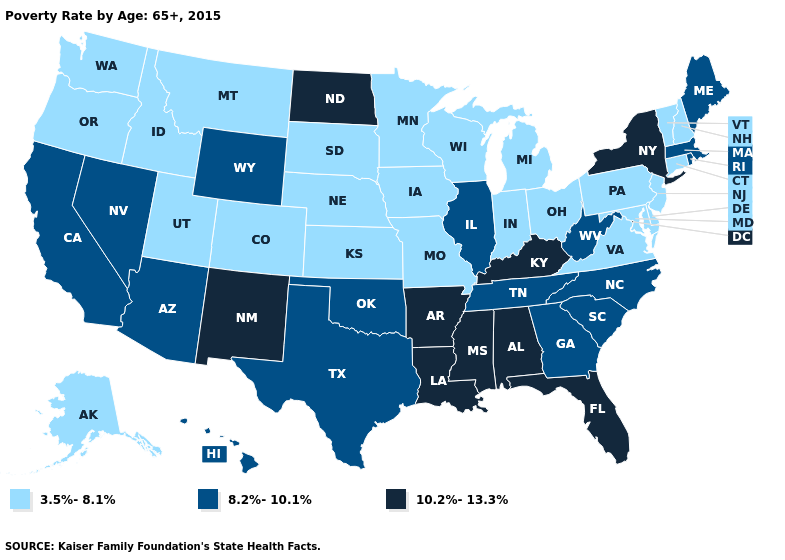Which states have the lowest value in the USA?
Write a very short answer. Alaska, Colorado, Connecticut, Delaware, Idaho, Indiana, Iowa, Kansas, Maryland, Michigan, Minnesota, Missouri, Montana, Nebraska, New Hampshire, New Jersey, Ohio, Oregon, Pennsylvania, South Dakota, Utah, Vermont, Virginia, Washington, Wisconsin. Does Georgia have the lowest value in the South?
Answer briefly. No. Name the states that have a value in the range 8.2%-10.1%?
Answer briefly. Arizona, California, Georgia, Hawaii, Illinois, Maine, Massachusetts, Nevada, North Carolina, Oklahoma, Rhode Island, South Carolina, Tennessee, Texas, West Virginia, Wyoming. Does Washington have a higher value than Hawaii?
Short answer required. No. What is the value of Pennsylvania?
Write a very short answer. 3.5%-8.1%. Does Alaska have the highest value in the USA?
Quick response, please. No. Does the first symbol in the legend represent the smallest category?
Answer briefly. Yes. Does California have a higher value than Utah?
Quick response, please. Yes. Name the states that have a value in the range 8.2%-10.1%?
Give a very brief answer. Arizona, California, Georgia, Hawaii, Illinois, Maine, Massachusetts, Nevada, North Carolina, Oklahoma, Rhode Island, South Carolina, Tennessee, Texas, West Virginia, Wyoming. Among the states that border Massachusetts , does New York have the lowest value?
Keep it brief. No. Name the states that have a value in the range 10.2%-13.3%?
Answer briefly. Alabama, Arkansas, Florida, Kentucky, Louisiana, Mississippi, New Mexico, New York, North Dakota. What is the value of Wisconsin?
Be succinct. 3.5%-8.1%. Does Virginia have the lowest value in the South?
Short answer required. Yes. What is the value of Pennsylvania?
Be succinct. 3.5%-8.1%. Does the map have missing data?
Answer briefly. No. 